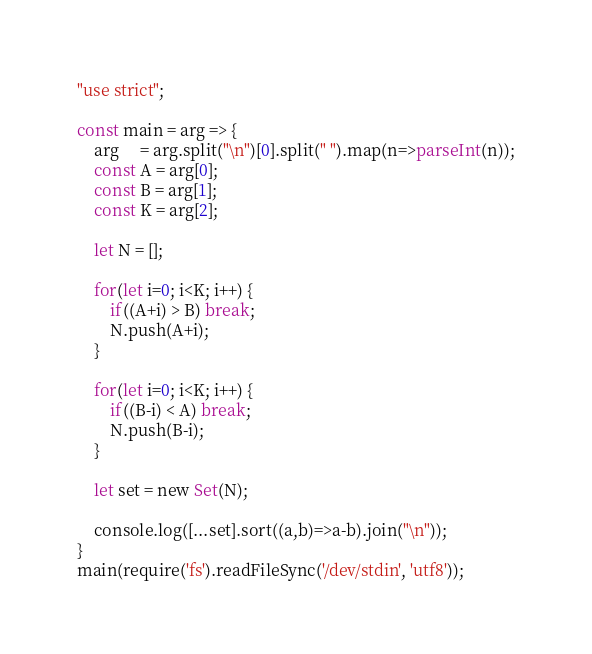<code> <loc_0><loc_0><loc_500><loc_500><_JavaScript_>"use strict";
    
const main = arg => {
    arg     = arg.split("\n")[0].split(" ").map(n=>parseInt(n));
    const A = arg[0];
    const B = arg[1];
    const K = arg[2];
    
    let N = [];
    
    for(let i=0; i<K; i++) {
        if((A+i) > B) break;
        N.push(A+i);
    }
    
    for(let i=0; i<K; i++) {
        if((B-i) < A) break;
        N.push(B-i);
    }
    
    let set = new Set(N);
    
    console.log([...set].sort((a,b)=>a-b).join("\n"));
}
main(require('fs').readFileSync('/dev/stdin', 'utf8'));</code> 